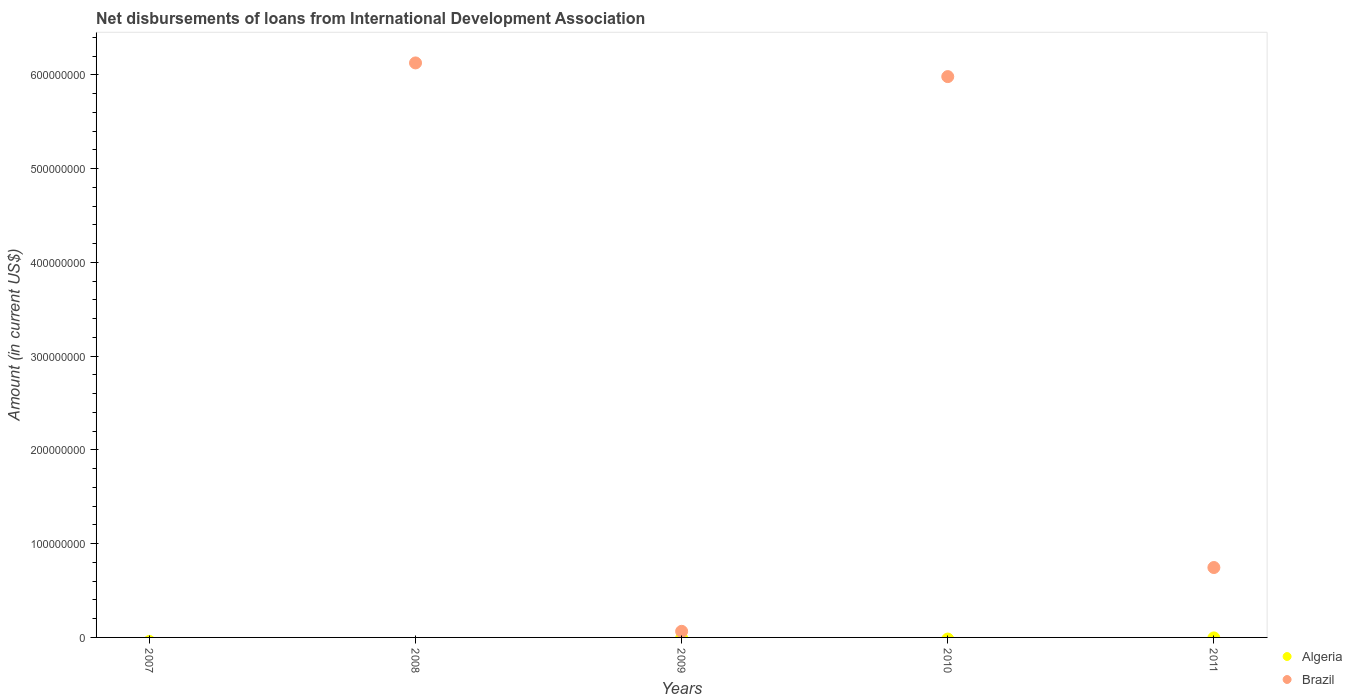How many different coloured dotlines are there?
Keep it short and to the point. 1. What is the amount of loans disbursed in Brazil in 2011?
Provide a short and direct response. 7.46e+07. Across all years, what is the maximum amount of loans disbursed in Brazil?
Give a very brief answer. 6.13e+08. Across all years, what is the minimum amount of loans disbursed in Brazil?
Make the answer very short. 0. What is the total amount of loans disbursed in Brazil in the graph?
Give a very brief answer. 1.29e+09. What is the difference between the amount of loans disbursed in Brazil in 2009 and that in 2010?
Make the answer very short. -5.92e+08. What is the difference between the amount of loans disbursed in Algeria in 2009 and the amount of loans disbursed in Brazil in 2007?
Offer a terse response. 0. What is the average amount of loans disbursed in Brazil per year?
Ensure brevity in your answer.  2.58e+08. What is the ratio of the amount of loans disbursed in Brazil in 2009 to that in 2010?
Ensure brevity in your answer.  0.01. What is the difference between the highest and the second highest amount of loans disbursed in Brazil?
Ensure brevity in your answer.  1.46e+07. What is the difference between the highest and the lowest amount of loans disbursed in Brazil?
Give a very brief answer. 6.13e+08. In how many years, is the amount of loans disbursed in Brazil greater than the average amount of loans disbursed in Brazil taken over all years?
Provide a short and direct response. 2. Is the sum of the amount of loans disbursed in Brazil in 2008 and 2009 greater than the maximum amount of loans disbursed in Algeria across all years?
Offer a very short reply. Yes. Does the amount of loans disbursed in Algeria monotonically increase over the years?
Your answer should be compact. No. Is the amount of loans disbursed in Brazil strictly less than the amount of loans disbursed in Algeria over the years?
Your answer should be compact. No. How many dotlines are there?
Provide a short and direct response. 1. How many years are there in the graph?
Your answer should be compact. 5. Are the values on the major ticks of Y-axis written in scientific E-notation?
Provide a succinct answer. No. Does the graph contain grids?
Provide a short and direct response. No. Where does the legend appear in the graph?
Make the answer very short. Bottom right. How many legend labels are there?
Offer a terse response. 2. How are the legend labels stacked?
Your answer should be compact. Vertical. What is the title of the graph?
Your response must be concise. Net disbursements of loans from International Development Association. Does "Peru" appear as one of the legend labels in the graph?
Keep it short and to the point. No. What is the Amount (in current US$) in Algeria in 2007?
Make the answer very short. 0. What is the Amount (in current US$) of Algeria in 2008?
Give a very brief answer. 0. What is the Amount (in current US$) in Brazil in 2008?
Your answer should be very brief. 6.13e+08. What is the Amount (in current US$) of Algeria in 2009?
Provide a short and direct response. 0. What is the Amount (in current US$) of Brazil in 2009?
Ensure brevity in your answer.  6.52e+06. What is the Amount (in current US$) in Brazil in 2010?
Keep it short and to the point. 5.98e+08. What is the Amount (in current US$) of Brazil in 2011?
Ensure brevity in your answer.  7.46e+07. Across all years, what is the maximum Amount (in current US$) in Brazil?
Ensure brevity in your answer.  6.13e+08. Across all years, what is the minimum Amount (in current US$) of Brazil?
Your answer should be compact. 0. What is the total Amount (in current US$) of Algeria in the graph?
Keep it short and to the point. 0. What is the total Amount (in current US$) in Brazil in the graph?
Your response must be concise. 1.29e+09. What is the difference between the Amount (in current US$) in Brazil in 2008 and that in 2009?
Offer a very short reply. 6.06e+08. What is the difference between the Amount (in current US$) of Brazil in 2008 and that in 2010?
Your response must be concise. 1.46e+07. What is the difference between the Amount (in current US$) of Brazil in 2008 and that in 2011?
Make the answer very short. 5.38e+08. What is the difference between the Amount (in current US$) of Brazil in 2009 and that in 2010?
Your response must be concise. -5.92e+08. What is the difference between the Amount (in current US$) in Brazil in 2009 and that in 2011?
Provide a succinct answer. -6.80e+07. What is the difference between the Amount (in current US$) of Brazil in 2010 and that in 2011?
Give a very brief answer. 5.24e+08. What is the average Amount (in current US$) of Brazil per year?
Provide a short and direct response. 2.58e+08. What is the ratio of the Amount (in current US$) in Brazil in 2008 to that in 2009?
Your answer should be very brief. 94.03. What is the ratio of the Amount (in current US$) in Brazil in 2008 to that in 2010?
Offer a very short reply. 1.02. What is the ratio of the Amount (in current US$) of Brazil in 2008 to that in 2011?
Keep it short and to the point. 8.22. What is the ratio of the Amount (in current US$) of Brazil in 2009 to that in 2010?
Your answer should be very brief. 0.01. What is the ratio of the Amount (in current US$) of Brazil in 2009 to that in 2011?
Your answer should be very brief. 0.09. What is the ratio of the Amount (in current US$) in Brazil in 2010 to that in 2011?
Your answer should be compact. 8.02. What is the difference between the highest and the second highest Amount (in current US$) in Brazil?
Provide a short and direct response. 1.46e+07. What is the difference between the highest and the lowest Amount (in current US$) in Brazil?
Your response must be concise. 6.13e+08. 